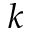<formula> <loc_0><loc_0><loc_500><loc_500>k</formula> 